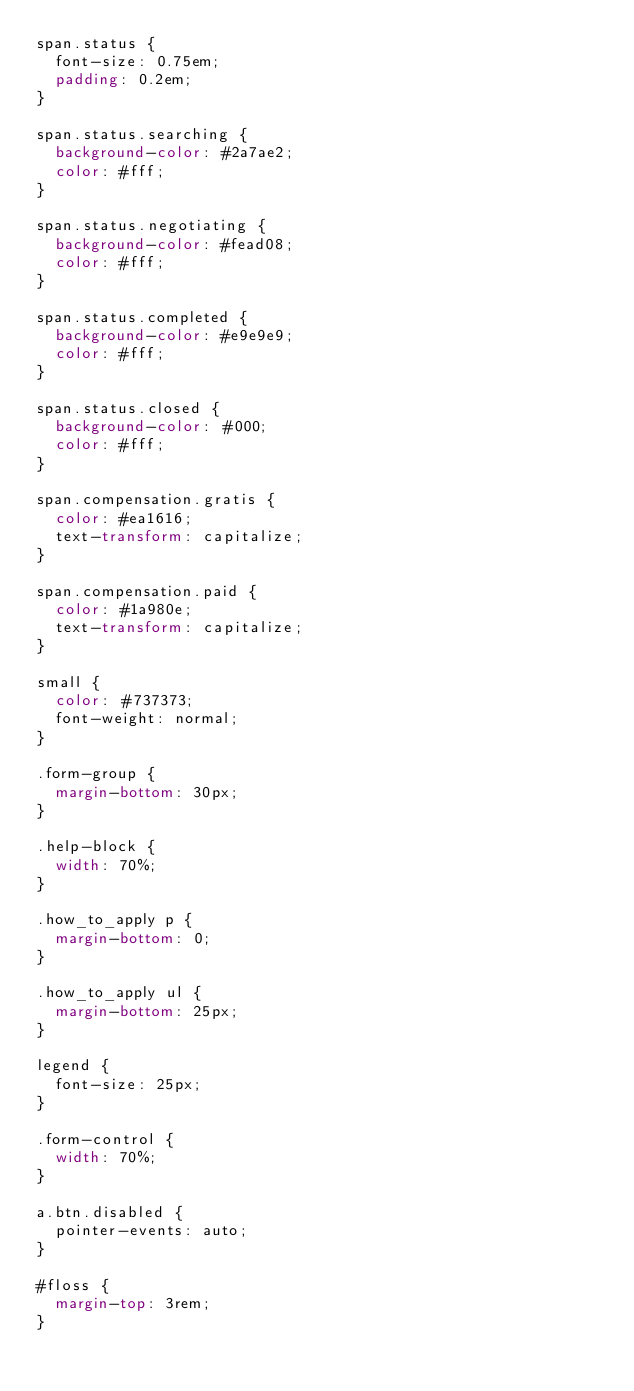Convert code to text. <code><loc_0><loc_0><loc_500><loc_500><_CSS_>span.status {
  font-size: 0.75em;
  padding: 0.2em;
}

span.status.searching {
  background-color: #2a7ae2;
  color: #fff;
}

span.status.negotiating {
  background-color: #fead08;
  color: #fff;
}

span.status.completed {
  background-color: #e9e9e9;
  color: #fff;
}

span.status.closed {
  background-color: #000;
  color: #fff;
}

span.compensation.gratis {
  color: #ea1616;
  text-transform: capitalize;
}

span.compensation.paid {
  color: #1a980e;
  text-transform: capitalize;
}

small {
  color: #737373;
  font-weight: normal;
}

.form-group {
  margin-bottom: 30px;
}

.help-block {
  width: 70%;
}

.how_to_apply p {
  margin-bottom: 0;
}

.how_to_apply ul {
  margin-bottom: 25px;
}

legend {
  font-size: 25px;
}

.form-control {
  width: 70%;
}

a.btn.disabled {
  pointer-events: auto;
}

#floss {
  margin-top: 3rem;
}
</code> 